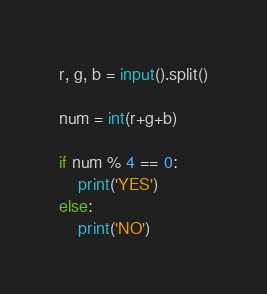Convert code to text. <code><loc_0><loc_0><loc_500><loc_500><_Python_>r, g, b = input().split()

num = int(r+g+b)

if num % 4 == 0:
    print('YES')
else:
    print('NO')
</code> 